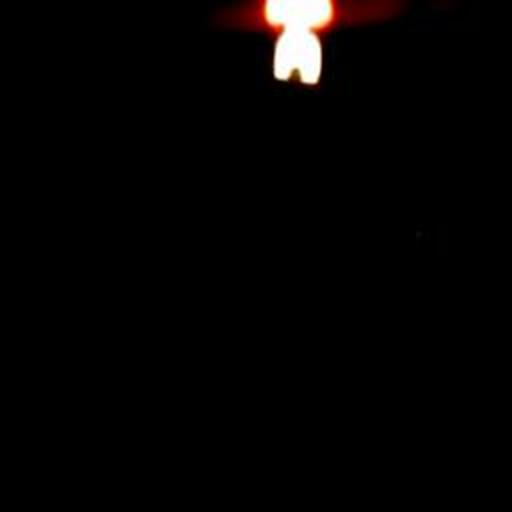Is there anything in the image that suggests a location or setting? The image provides limited context regarding location or setting, but the presence of the flame suggests an intimate space or a setting where lighting is minimal and focused, such as during a power outage or in a space with intentional mood lighting. 